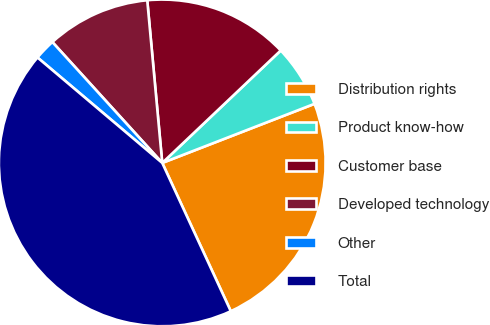<chart> <loc_0><loc_0><loc_500><loc_500><pie_chart><fcel>Distribution rights<fcel>Product know-how<fcel>Customer base<fcel>Developed technology<fcel>Other<fcel>Total<nl><fcel>24.0%<fcel>6.19%<fcel>14.38%<fcel>10.28%<fcel>2.09%<fcel>43.06%<nl></chart> 